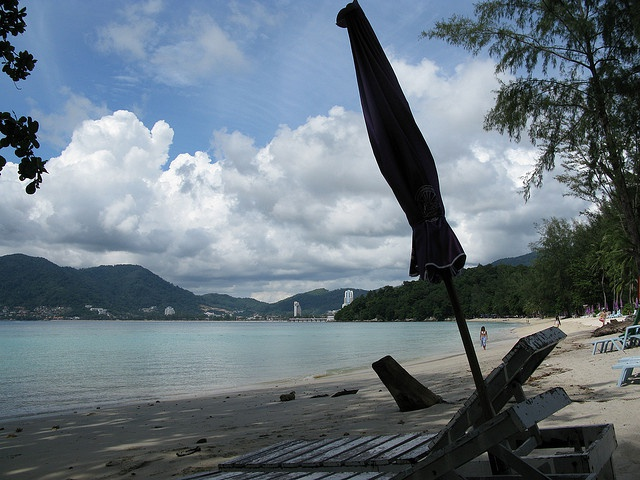Describe the objects in this image and their specific colors. I can see umbrella in black, darkgray, gray, and lightgray tones, chair in black, gray, and purple tones, chair in black, gray, and purple tones, chair in black, darkgray, gray, and lightblue tones, and chair in black, darkgray, and gray tones in this image. 